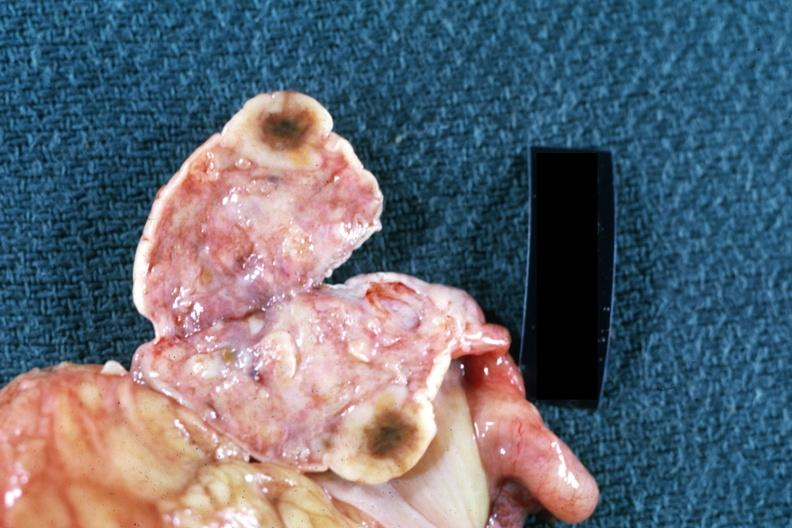what is present?
Answer the question using a single word or phrase. Female reproductive 